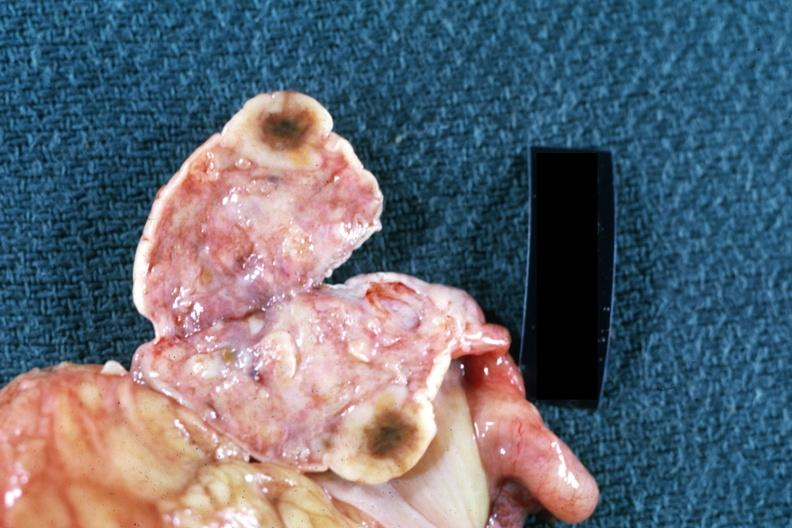what is present?
Answer the question using a single word or phrase. Female reproductive 